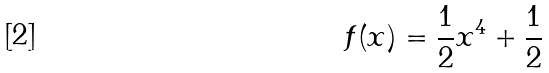<formula> <loc_0><loc_0><loc_500><loc_500>f ( x ) = \frac { 1 } { 2 } x ^ { 4 } + \frac { 1 } { 2 }</formula> 